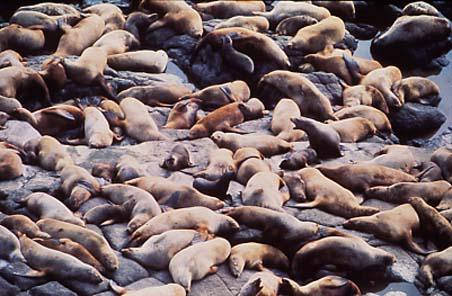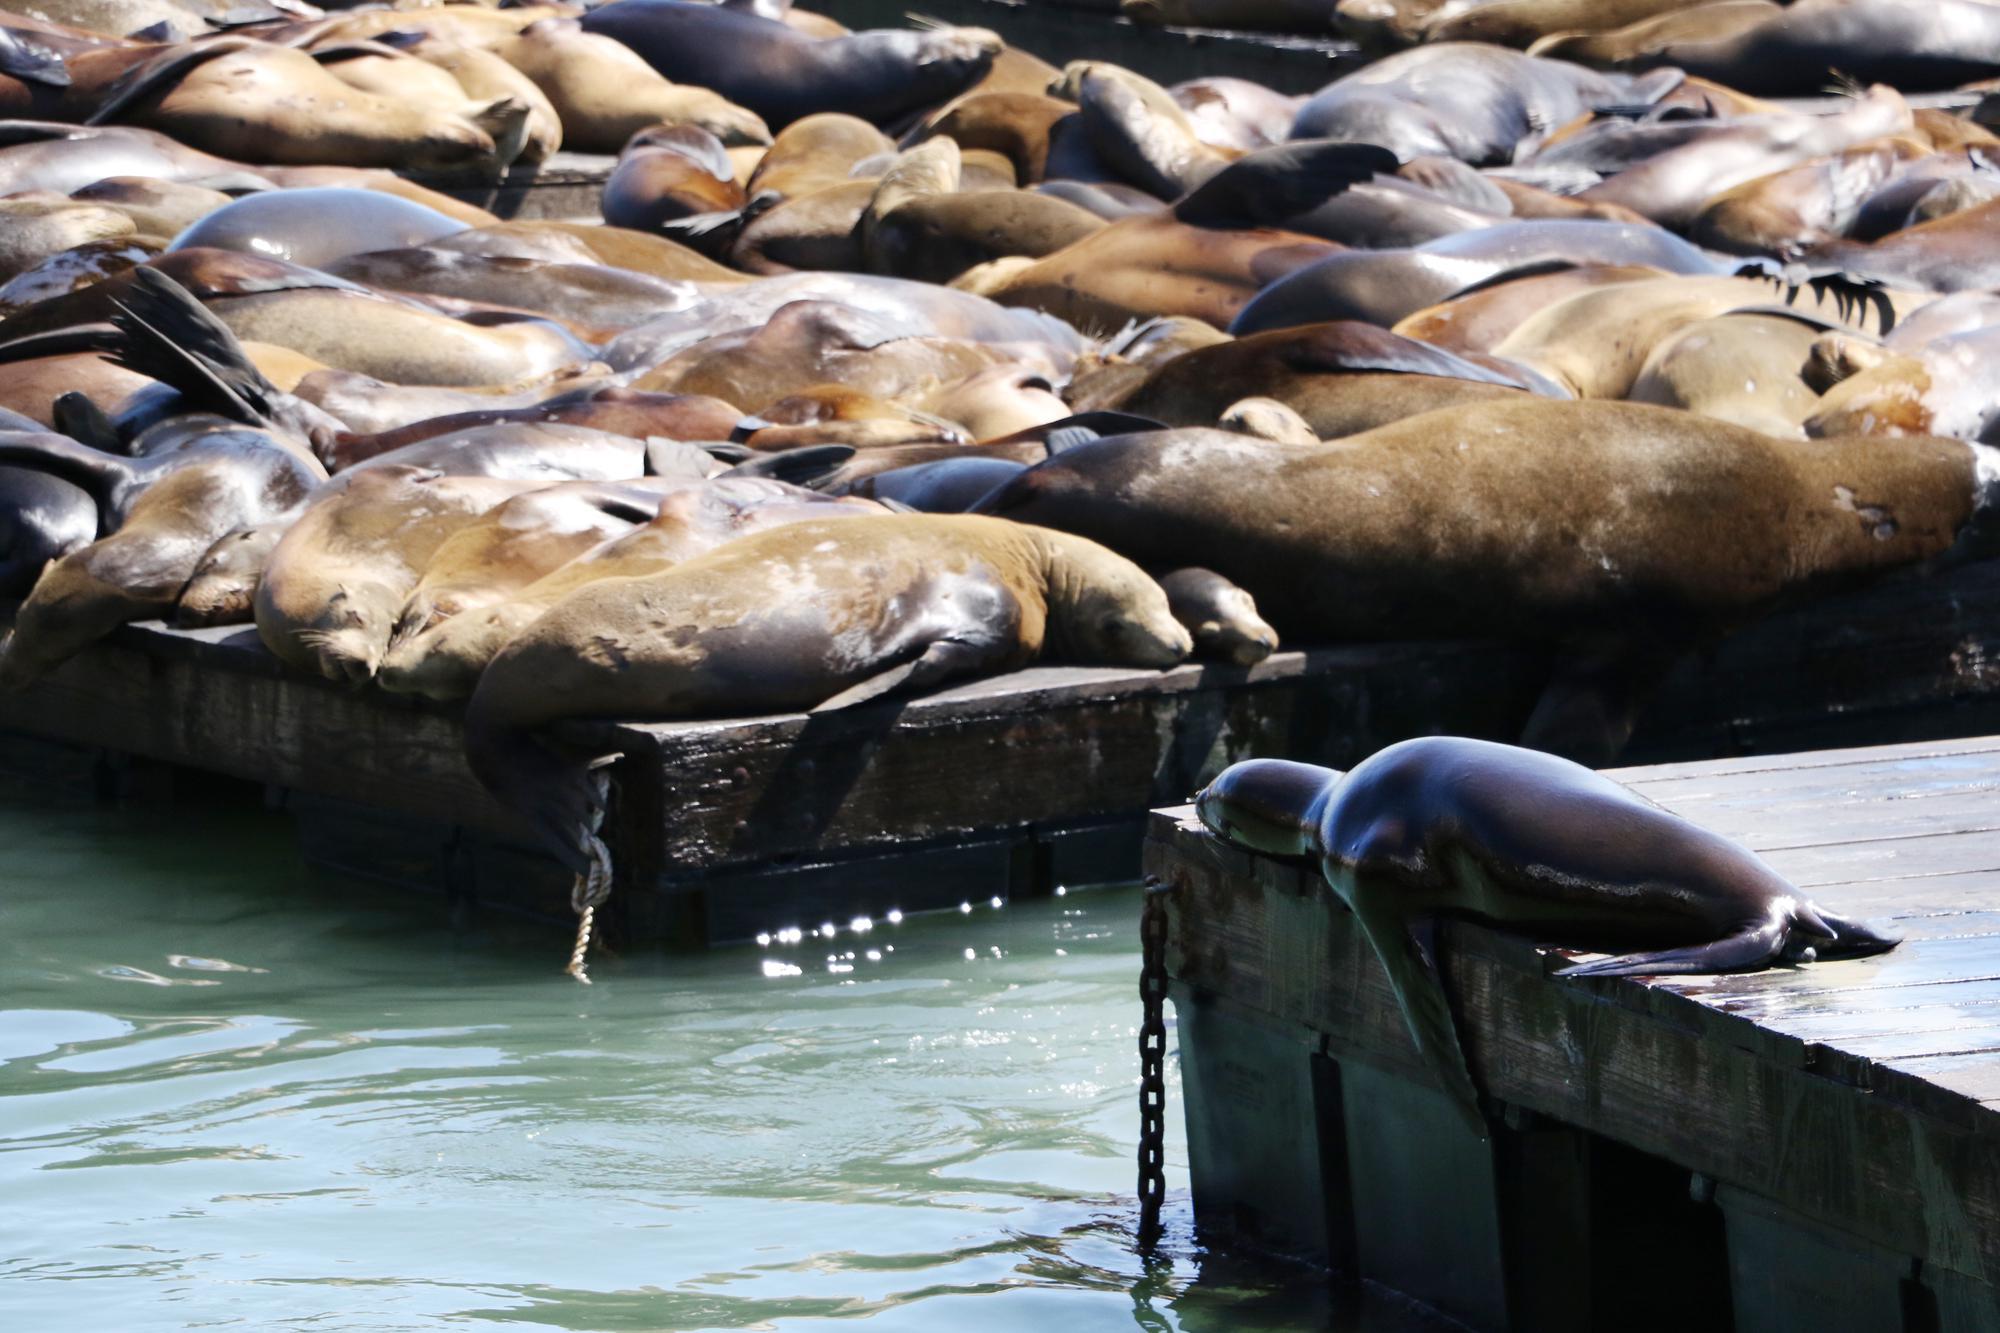The first image is the image on the left, the second image is the image on the right. Evaluate the accuracy of this statement regarding the images: "In at least one of the images, there are vertical wooden poles sticking up from the docks.". Is it true? Answer yes or no. No. The first image is the image on the left, the second image is the image on the right. Examine the images to the left and right. Is the description "The corners of floating platforms piled with reclining seals are visible in just one image." accurate? Answer yes or no. Yes. 